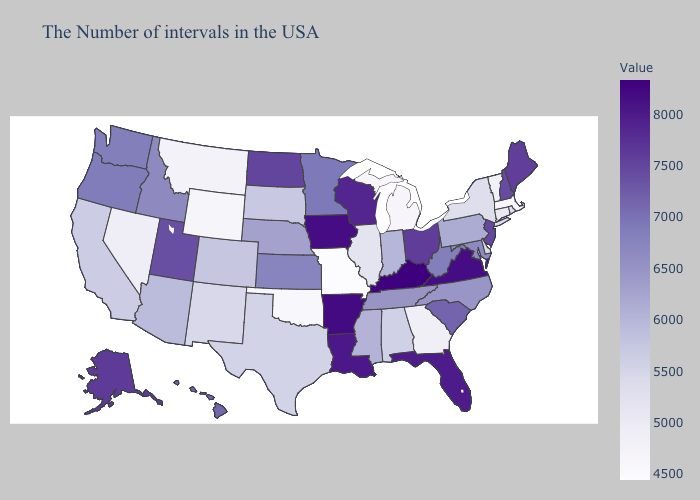Does Tennessee have the lowest value in the South?
Quick response, please. No. Does New Mexico have the highest value in the USA?
Concise answer only. No. Which states have the lowest value in the USA?
Short answer required. Missouri. Does New Mexico have the highest value in the West?
Quick response, please. No. Does North Carolina have the highest value in the South?
Quick response, please. No. Is the legend a continuous bar?
Be succinct. Yes. 